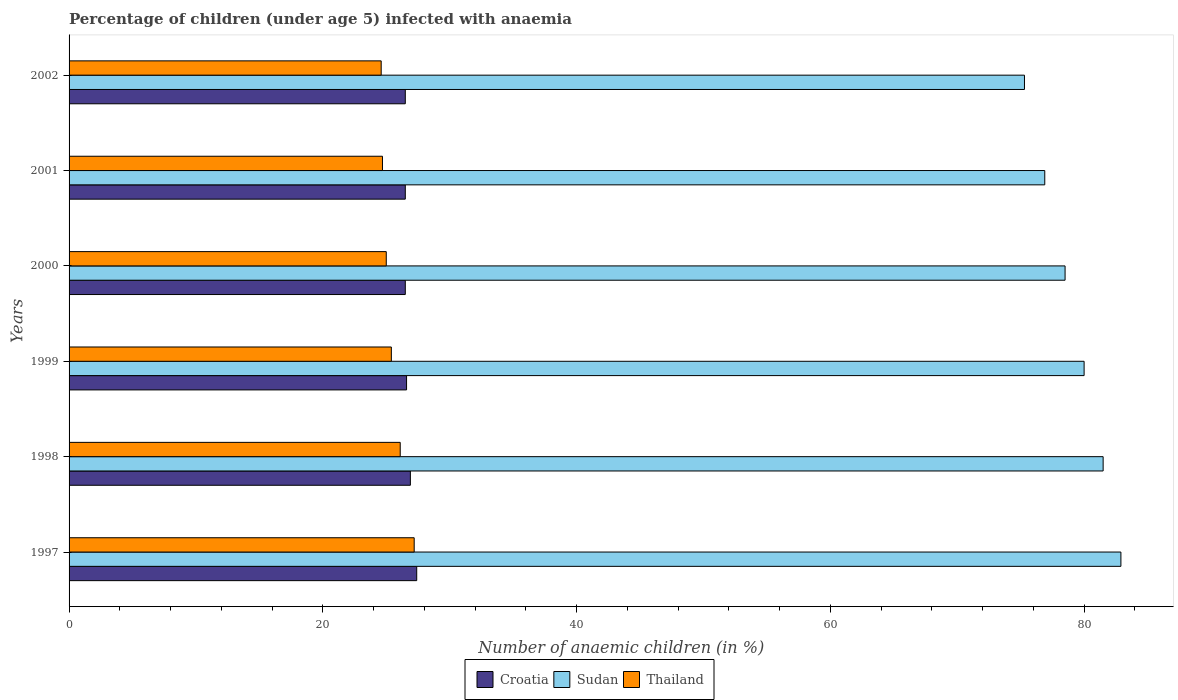How many different coloured bars are there?
Your answer should be very brief. 3. Are the number of bars on each tick of the Y-axis equal?
Your answer should be very brief. Yes. How many bars are there on the 1st tick from the top?
Ensure brevity in your answer.  3. How many bars are there on the 5th tick from the bottom?
Your answer should be compact. 3. What is the label of the 1st group of bars from the top?
Your response must be concise. 2002. In how many cases, is the number of bars for a given year not equal to the number of legend labels?
Offer a terse response. 0. Across all years, what is the maximum percentage of children infected with anaemia in in Sudan?
Give a very brief answer. 82.9. Across all years, what is the minimum percentage of children infected with anaemia in in Thailand?
Provide a succinct answer. 24.6. What is the total percentage of children infected with anaemia in in Thailand in the graph?
Offer a very short reply. 153. What is the difference between the percentage of children infected with anaemia in in Croatia in 1997 and that in 2000?
Your answer should be very brief. 0.9. What is the difference between the percentage of children infected with anaemia in in Thailand in 2000 and the percentage of children infected with anaemia in in Sudan in 1998?
Your response must be concise. -56.5. What is the average percentage of children infected with anaemia in in Sudan per year?
Offer a terse response. 79.18. In the year 1998, what is the difference between the percentage of children infected with anaemia in in Thailand and percentage of children infected with anaemia in in Sudan?
Your response must be concise. -55.4. In how many years, is the percentage of children infected with anaemia in in Thailand greater than 72 %?
Your answer should be compact. 0. What is the ratio of the percentage of children infected with anaemia in in Croatia in 1998 to that in 2001?
Offer a terse response. 1.02. Is the percentage of children infected with anaemia in in Thailand in 1998 less than that in 2000?
Ensure brevity in your answer.  No. Is the difference between the percentage of children infected with anaemia in in Thailand in 1999 and 2000 greater than the difference between the percentage of children infected with anaemia in in Sudan in 1999 and 2000?
Make the answer very short. No. What is the difference between the highest and the second highest percentage of children infected with anaemia in in Sudan?
Give a very brief answer. 1.4. What is the difference between the highest and the lowest percentage of children infected with anaemia in in Thailand?
Offer a very short reply. 2.6. In how many years, is the percentage of children infected with anaemia in in Sudan greater than the average percentage of children infected with anaemia in in Sudan taken over all years?
Your answer should be compact. 3. What does the 2nd bar from the top in 1997 represents?
Provide a succinct answer. Sudan. What does the 3rd bar from the bottom in 2000 represents?
Your answer should be very brief. Thailand. How many bars are there?
Provide a succinct answer. 18. Are all the bars in the graph horizontal?
Your response must be concise. Yes. Does the graph contain any zero values?
Keep it short and to the point. No. Does the graph contain grids?
Ensure brevity in your answer.  No. Where does the legend appear in the graph?
Your answer should be compact. Bottom center. How many legend labels are there?
Give a very brief answer. 3. What is the title of the graph?
Your answer should be very brief. Percentage of children (under age 5) infected with anaemia. Does "Malaysia" appear as one of the legend labels in the graph?
Keep it short and to the point. No. What is the label or title of the X-axis?
Ensure brevity in your answer.  Number of anaemic children (in %). What is the label or title of the Y-axis?
Your response must be concise. Years. What is the Number of anaemic children (in %) in Croatia in 1997?
Your response must be concise. 27.4. What is the Number of anaemic children (in %) of Sudan in 1997?
Give a very brief answer. 82.9. What is the Number of anaemic children (in %) of Thailand in 1997?
Give a very brief answer. 27.2. What is the Number of anaemic children (in %) of Croatia in 1998?
Offer a terse response. 26.9. What is the Number of anaemic children (in %) in Sudan in 1998?
Your response must be concise. 81.5. What is the Number of anaemic children (in %) in Thailand in 1998?
Offer a terse response. 26.1. What is the Number of anaemic children (in %) in Croatia in 1999?
Ensure brevity in your answer.  26.6. What is the Number of anaemic children (in %) in Sudan in 1999?
Offer a very short reply. 80. What is the Number of anaemic children (in %) in Thailand in 1999?
Keep it short and to the point. 25.4. What is the Number of anaemic children (in %) of Croatia in 2000?
Your response must be concise. 26.5. What is the Number of anaemic children (in %) of Sudan in 2000?
Your response must be concise. 78.5. What is the Number of anaemic children (in %) in Croatia in 2001?
Offer a terse response. 26.5. What is the Number of anaemic children (in %) of Sudan in 2001?
Your answer should be very brief. 76.9. What is the Number of anaemic children (in %) of Thailand in 2001?
Your answer should be very brief. 24.7. What is the Number of anaemic children (in %) in Croatia in 2002?
Provide a succinct answer. 26.5. What is the Number of anaemic children (in %) in Sudan in 2002?
Provide a short and direct response. 75.3. What is the Number of anaemic children (in %) of Thailand in 2002?
Your answer should be compact. 24.6. Across all years, what is the maximum Number of anaemic children (in %) of Croatia?
Provide a succinct answer. 27.4. Across all years, what is the maximum Number of anaemic children (in %) in Sudan?
Your response must be concise. 82.9. Across all years, what is the maximum Number of anaemic children (in %) of Thailand?
Keep it short and to the point. 27.2. Across all years, what is the minimum Number of anaemic children (in %) in Sudan?
Your response must be concise. 75.3. Across all years, what is the minimum Number of anaemic children (in %) in Thailand?
Keep it short and to the point. 24.6. What is the total Number of anaemic children (in %) in Croatia in the graph?
Provide a succinct answer. 160.4. What is the total Number of anaemic children (in %) in Sudan in the graph?
Give a very brief answer. 475.1. What is the total Number of anaemic children (in %) of Thailand in the graph?
Provide a short and direct response. 153. What is the difference between the Number of anaemic children (in %) in Croatia in 1997 and that in 2000?
Your response must be concise. 0.9. What is the difference between the Number of anaemic children (in %) in Sudan in 1997 and that in 2000?
Keep it short and to the point. 4.4. What is the difference between the Number of anaemic children (in %) of Thailand in 1997 and that in 2000?
Offer a very short reply. 2.2. What is the difference between the Number of anaemic children (in %) in Croatia in 1997 and that in 2001?
Offer a terse response. 0.9. What is the difference between the Number of anaemic children (in %) of Croatia in 1997 and that in 2002?
Make the answer very short. 0.9. What is the difference between the Number of anaemic children (in %) of Thailand in 1997 and that in 2002?
Your answer should be very brief. 2.6. What is the difference between the Number of anaemic children (in %) of Sudan in 1998 and that in 1999?
Your answer should be compact. 1.5. What is the difference between the Number of anaemic children (in %) in Croatia in 1998 and that in 2001?
Provide a succinct answer. 0.4. What is the difference between the Number of anaemic children (in %) of Sudan in 1998 and that in 2001?
Give a very brief answer. 4.6. What is the difference between the Number of anaemic children (in %) in Thailand in 1998 and that in 2001?
Ensure brevity in your answer.  1.4. What is the difference between the Number of anaemic children (in %) of Croatia in 1999 and that in 2000?
Make the answer very short. 0.1. What is the difference between the Number of anaemic children (in %) of Sudan in 1999 and that in 2000?
Provide a short and direct response. 1.5. What is the difference between the Number of anaemic children (in %) in Sudan in 1999 and that in 2001?
Provide a succinct answer. 3.1. What is the difference between the Number of anaemic children (in %) in Thailand in 1999 and that in 2001?
Keep it short and to the point. 0.7. What is the difference between the Number of anaemic children (in %) in Croatia in 1999 and that in 2002?
Your response must be concise. 0.1. What is the difference between the Number of anaemic children (in %) of Croatia in 2000 and that in 2001?
Provide a succinct answer. 0. What is the difference between the Number of anaemic children (in %) of Croatia in 2000 and that in 2002?
Ensure brevity in your answer.  0. What is the difference between the Number of anaemic children (in %) in Sudan in 2000 and that in 2002?
Your response must be concise. 3.2. What is the difference between the Number of anaemic children (in %) in Thailand in 2000 and that in 2002?
Keep it short and to the point. 0.4. What is the difference between the Number of anaemic children (in %) of Croatia in 2001 and that in 2002?
Make the answer very short. 0. What is the difference between the Number of anaemic children (in %) in Thailand in 2001 and that in 2002?
Your answer should be very brief. 0.1. What is the difference between the Number of anaemic children (in %) in Croatia in 1997 and the Number of anaemic children (in %) in Sudan in 1998?
Your answer should be very brief. -54.1. What is the difference between the Number of anaemic children (in %) in Croatia in 1997 and the Number of anaemic children (in %) in Thailand in 1998?
Provide a succinct answer. 1.3. What is the difference between the Number of anaemic children (in %) in Sudan in 1997 and the Number of anaemic children (in %) in Thailand in 1998?
Your answer should be very brief. 56.8. What is the difference between the Number of anaemic children (in %) of Croatia in 1997 and the Number of anaemic children (in %) of Sudan in 1999?
Offer a very short reply. -52.6. What is the difference between the Number of anaemic children (in %) in Sudan in 1997 and the Number of anaemic children (in %) in Thailand in 1999?
Ensure brevity in your answer.  57.5. What is the difference between the Number of anaemic children (in %) of Croatia in 1997 and the Number of anaemic children (in %) of Sudan in 2000?
Provide a short and direct response. -51.1. What is the difference between the Number of anaemic children (in %) of Sudan in 1997 and the Number of anaemic children (in %) of Thailand in 2000?
Give a very brief answer. 57.9. What is the difference between the Number of anaemic children (in %) in Croatia in 1997 and the Number of anaemic children (in %) in Sudan in 2001?
Keep it short and to the point. -49.5. What is the difference between the Number of anaemic children (in %) of Croatia in 1997 and the Number of anaemic children (in %) of Thailand in 2001?
Offer a very short reply. 2.7. What is the difference between the Number of anaemic children (in %) of Sudan in 1997 and the Number of anaemic children (in %) of Thailand in 2001?
Your answer should be compact. 58.2. What is the difference between the Number of anaemic children (in %) in Croatia in 1997 and the Number of anaemic children (in %) in Sudan in 2002?
Your answer should be compact. -47.9. What is the difference between the Number of anaemic children (in %) of Croatia in 1997 and the Number of anaemic children (in %) of Thailand in 2002?
Offer a terse response. 2.8. What is the difference between the Number of anaemic children (in %) in Sudan in 1997 and the Number of anaemic children (in %) in Thailand in 2002?
Provide a succinct answer. 58.3. What is the difference between the Number of anaemic children (in %) in Croatia in 1998 and the Number of anaemic children (in %) in Sudan in 1999?
Provide a succinct answer. -53.1. What is the difference between the Number of anaemic children (in %) of Sudan in 1998 and the Number of anaemic children (in %) of Thailand in 1999?
Offer a terse response. 56.1. What is the difference between the Number of anaemic children (in %) of Croatia in 1998 and the Number of anaemic children (in %) of Sudan in 2000?
Provide a succinct answer. -51.6. What is the difference between the Number of anaemic children (in %) in Sudan in 1998 and the Number of anaemic children (in %) in Thailand in 2000?
Ensure brevity in your answer.  56.5. What is the difference between the Number of anaemic children (in %) in Croatia in 1998 and the Number of anaemic children (in %) in Thailand in 2001?
Your answer should be compact. 2.2. What is the difference between the Number of anaemic children (in %) in Sudan in 1998 and the Number of anaemic children (in %) in Thailand in 2001?
Your answer should be compact. 56.8. What is the difference between the Number of anaemic children (in %) in Croatia in 1998 and the Number of anaemic children (in %) in Sudan in 2002?
Offer a terse response. -48.4. What is the difference between the Number of anaemic children (in %) of Croatia in 1998 and the Number of anaemic children (in %) of Thailand in 2002?
Give a very brief answer. 2.3. What is the difference between the Number of anaemic children (in %) in Sudan in 1998 and the Number of anaemic children (in %) in Thailand in 2002?
Provide a succinct answer. 56.9. What is the difference between the Number of anaemic children (in %) of Croatia in 1999 and the Number of anaemic children (in %) of Sudan in 2000?
Make the answer very short. -51.9. What is the difference between the Number of anaemic children (in %) of Croatia in 1999 and the Number of anaemic children (in %) of Sudan in 2001?
Provide a succinct answer. -50.3. What is the difference between the Number of anaemic children (in %) of Croatia in 1999 and the Number of anaemic children (in %) of Thailand in 2001?
Your answer should be compact. 1.9. What is the difference between the Number of anaemic children (in %) in Sudan in 1999 and the Number of anaemic children (in %) in Thailand in 2001?
Your response must be concise. 55.3. What is the difference between the Number of anaemic children (in %) in Croatia in 1999 and the Number of anaemic children (in %) in Sudan in 2002?
Give a very brief answer. -48.7. What is the difference between the Number of anaemic children (in %) in Sudan in 1999 and the Number of anaemic children (in %) in Thailand in 2002?
Offer a terse response. 55.4. What is the difference between the Number of anaemic children (in %) in Croatia in 2000 and the Number of anaemic children (in %) in Sudan in 2001?
Offer a terse response. -50.4. What is the difference between the Number of anaemic children (in %) in Croatia in 2000 and the Number of anaemic children (in %) in Thailand in 2001?
Offer a terse response. 1.8. What is the difference between the Number of anaemic children (in %) in Sudan in 2000 and the Number of anaemic children (in %) in Thailand in 2001?
Ensure brevity in your answer.  53.8. What is the difference between the Number of anaemic children (in %) in Croatia in 2000 and the Number of anaemic children (in %) in Sudan in 2002?
Provide a succinct answer. -48.8. What is the difference between the Number of anaemic children (in %) of Croatia in 2000 and the Number of anaemic children (in %) of Thailand in 2002?
Make the answer very short. 1.9. What is the difference between the Number of anaemic children (in %) of Sudan in 2000 and the Number of anaemic children (in %) of Thailand in 2002?
Provide a succinct answer. 53.9. What is the difference between the Number of anaemic children (in %) of Croatia in 2001 and the Number of anaemic children (in %) of Sudan in 2002?
Offer a terse response. -48.8. What is the difference between the Number of anaemic children (in %) in Sudan in 2001 and the Number of anaemic children (in %) in Thailand in 2002?
Keep it short and to the point. 52.3. What is the average Number of anaemic children (in %) of Croatia per year?
Make the answer very short. 26.73. What is the average Number of anaemic children (in %) in Sudan per year?
Your response must be concise. 79.18. What is the average Number of anaemic children (in %) of Thailand per year?
Your answer should be compact. 25.5. In the year 1997, what is the difference between the Number of anaemic children (in %) in Croatia and Number of anaemic children (in %) in Sudan?
Your answer should be very brief. -55.5. In the year 1997, what is the difference between the Number of anaemic children (in %) in Croatia and Number of anaemic children (in %) in Thailand?
Provide a succinct answer. 0.2. In the year 1997, what is the difference between the Number of anaemic children (in %) in Sudan and Number of anaemic children (in %) in Thailand?
Keep it short and to the point. 55.7. In the year 1998, what is the difference between the Number of anaemic children (in %) in Croatia and Number of anaemic children (in %) in Sudan?
Your answer should be very brief. -54.6. In the year 1998, what is the difference between the Number of anaemic children (in %) of Croatia and Number of anaemic children (in %) of Thailand?
Ensure brevity in your answer.  0.8. In the year 1998, what is the difference between the Number of anaemic children (in %) in Sudan and Number of anaemic children (in %) in Thailand?
Ensure brevity in your answer.  55.4. In the year 1999, what is the difference between the Number of anaemic children (in %) in Croatia and Number of anaemic children (in %) in Sudan?
Offer a very short reply. -53.4. In the year 1999, what is the difference between the Number of anaemic children (in %) in Croatia and Number of anaemic children (in %) in Thailand?
Offer a terse response. 1.2. In the year 1999, what is the difference between the Number of anaemic children (in %) in Sudan and Number of anaemic children (in %) in Thailand?
Provide a succinct answer. 54.6. In the year 2000, what is the difference between the Number of anaemic children (in %) of Croatia and Number of anaemic children (in %) of Sudan?
Keep it short and to the point. -52. In the year 2000, what is the difference between the Number of anaemic children (in %) of Croatia and Number of anaemic children (in %) of Thailand?
Give a very brief answer. 1.5. In the year 2000, what is the difference between the Number of anaemic children (in %) of Sudan and Number of anaemic children (in %) of Thailand?
Provide a succinct answer. 53.5. In the year 2001, what is the difference between the Number of anaemic children (in %) of Croatia and Number of anaemic children (in %) of Sudan?
Provide a succinct answer. -50.4. In the year 2001, what is the difference between the Number of anaemic children (in %) in Sudan and Number of anaemic children (in %) in Thailand?
Make the answer very short. 52.2. In the year 2002, what is the difference between the Number of anaemic children (in %) in Croatia and Number of anaemic children (in %) in Sudan?
Your answer should be compact. -48.8. In the year 2002, what is the difference between the Number of anaemic children (in %) in Sudan and Number of anaemic children (in %) in Thailand?
Keep it short and to the point. 50.7. What is the ratio of the Number of anaemic children (in %) of Croatia in 1997 to that in 1998?
Your answer should be very brief. 1.02. What is the ratio of the Number of anaemic children (in %) of Sudan in 1997 to that in 1998?
Keep it short and to the point. 1.02. What is the ratio of the Number of anaemic children (in %) in Thailand in 1997 to that in 1998?
Your answer should be compact. 1.04. What is the ratio of the Number of anaemic children (in %) in Croatia in 1997 to that in 1999?
Your answer should be very brief. 1.03. What is the ratio of the Number of anaemic children (in %) of Sudan in 1997 to that in 1999?
Provide a short and direct response. 1.04. What is the ratio of the Number of anaemic children (in %) in Thailand in 1997 to that in 1999?
Your answer should be compact. 1.07. What is the ratio of the Number of anaemic children (in %) in Croatia in 1997 to that in 2000?
Your answer should be very brief. 1.03. What is the ratio of the Number of anaemic children (in %) in Sudan in 1997 to that in 2000?
Your answer should be very brief. 1.06. What is the ratio of the Number of anaemic children (in %) of Thailand in 1997 to that in 2000?
Give a very brief answer. 1.09. What is the ratio of the Number of anaemic children (in %) in Croatia in 1997 to that in 2001?
Offer a very short reply. 1.03. What is the ratio of the Number of anaemic children (in %) of Sudan in 1997 to that in 2001?
Provide a succinct answer. 1.08. What is the ratio of the Number of anaemic children (in %) of Thailand in 1997 to that in 2001?
Provide a short and direct response. 1.1. What is the ratio of the Number of anaemic children (in %) in Croatia in 1997 to that in 2002?
Your response must be concise. 1.03. What is the ratio of the Number of anaemic children (in %) in Sudan in 1997 to that in 2002?
Offer a terse response. 1.1. What is the ratio of the Number of anaemic children (in %) of Thailand in 1997 to that in 2002?
Your response must be concise. 1.11. What is the ratio of the Number of anaemic children (in %) in Croatia in 1998 to that in 1999?
Provide a succinct answer. 1.01. What is the ratio of the Number of anaemic children (in %) of Sudan in 1998 to that in 1999?
Offer a terse response. 1.02. What is the ratio of the Number of anaemic children (in %) of Thailand in 1998 to that in 1999?
Provide a succinct answer. 1.03. What is the ratio of the Number of anaemic children (in %) of Croatia in 1998 to that in 2000?
Offer a terse response. 1.02. What is the ratio of the Number of anaemic children (in %) in Sudan in 1998 to that in 2000?
Your answer should be very brief. 1.04. What is the ratio of the Number of anaemic children (in %) in Thailand in 1998 to that in 2000?
Give a very brief answer. 1.04. What is the ratio of the Number of anaemic children (in %) of Croatia in 1998 to that in 2001?
Provide a short and direct response. 1.02. What is the ratio of the Number of anaemic children (in %) of Sudan in 1998 to that in 2001?
Keep it short and to the point. 1.06. What is the ratio of the Number of anaemic children (in %) of Thailand in 1998 to that in 2001?
Give a very brief answer. 1.06. What is the ratio of the Number of anaemic children (in %) of Croatia in 1998 to that in 2002?
Your answer should be compact. 1.02. What is the ratio of the Number of anaemic children (in %) in Sudan in 1998 to that in 2002?
Your answer should be very brief. 1.08. What is the ratio of the Number of anaemic children (in %) of Thailand in 1998 to that in 2002?
Ensure brevity in your answer.  1.06. What is the ratio of the Number of anaemic children (in %) of Sudan in 1999 to that in 2000?
Your answer should be compact. 1.02. What is the ratio of the Number of anaemic children (in %) of Thailand in 1999 to that in 2000?
Provide a short and direct response. 1.02. What is the ratio of the Number of anaemic children (in %) in Croatia in 1999 to that in 2001?
Your response must be concise. 1. What is the ratio of the Number of anaemic children (in %) of Sudan in 1999 to that in 2001?
Your answer should be very brief. 1.04. What is the ratio of the Number of anaemic children (in %) of Thailand in 1999 to that in 2001?
Your answer should be very brief. 1.03. What is the ratio of the Number of anaemic children (in %) in Croatia in 1999 to that in 2002?
Provide a succinct answer. 1. What is the ratio of the Number of anaemic children (in %) of Sudan in 1999 to that in 2002?
Your response must be concise. 1.06. What is the ratio of the Number of anaemic children (in %) in Thailand in 1999 to that in 2002?
Your answer should be compact. 1.03. What is the ratio of the Number of anaemic children (in %) in Sudan in 2000 to that in 2001?
Give a very brief answer. 1.02. What is the ratio of the Number of anaemic children (in %) of Thailand in 2000 to that in 2001?
Your response must be concise. 1.01. What is the ratio of the Number of anaemic children (in %) of Croatia in 2000 to that in 2002?
Make the answer very short. 1. What is the ratio of the Number of anaemic children (in %) of Sudan in 2000 to that in 2002?
Offer a terse response. 1.04. What is the ratio of the Number of anaemic children (in %) of Thailand in 2000 to that in 2002?
Offer a terse response. 1.02. What is the ratio of the Number of anaemic children (in %) of Croatia in 2001 to that in 2002?
Provide a succinct answer. 1. What is the ratio of the Number of anaemic children (in %) of Sudan in 2001 to that in 2002?
Keep it short and to the point. 1.02. What is the difference between the highest and the second highest Number of anaemic children (in %) in Croatia?
Offer a terse response. 0.5. What is the difference between the highest and the second highest Number of anaemic children (in %) of Sudan?
Give a very brief answer. 1.4. What is the difference between the highest and the lowest Number of anaemic children (in %) of Croatia?
Your answer should be very brief. 0.9. What is the difference between the highest and the lowest Number of anaemic children (in %) of Thailand?
Offer a terse response. 2.6. 